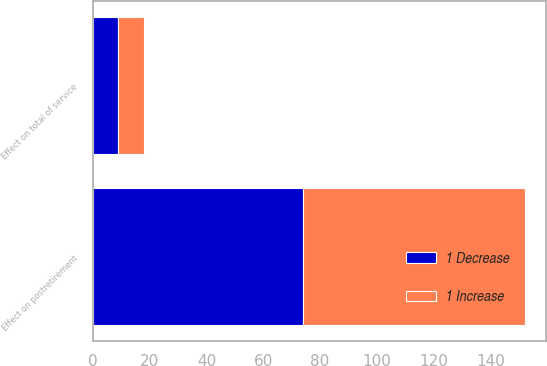Convert chart to OTSL. <chart><loc_0><loc_0><loc_500><loc_500><stacked_bar_chart><ecel><fcel>Effect on total of service<fcel>Effect on postretirement<nl><fcel>1 Decrease<fcel>9<fcel>74<nl><fcel>1 Increase<fcel>9<fcel>78<nl></chart> 